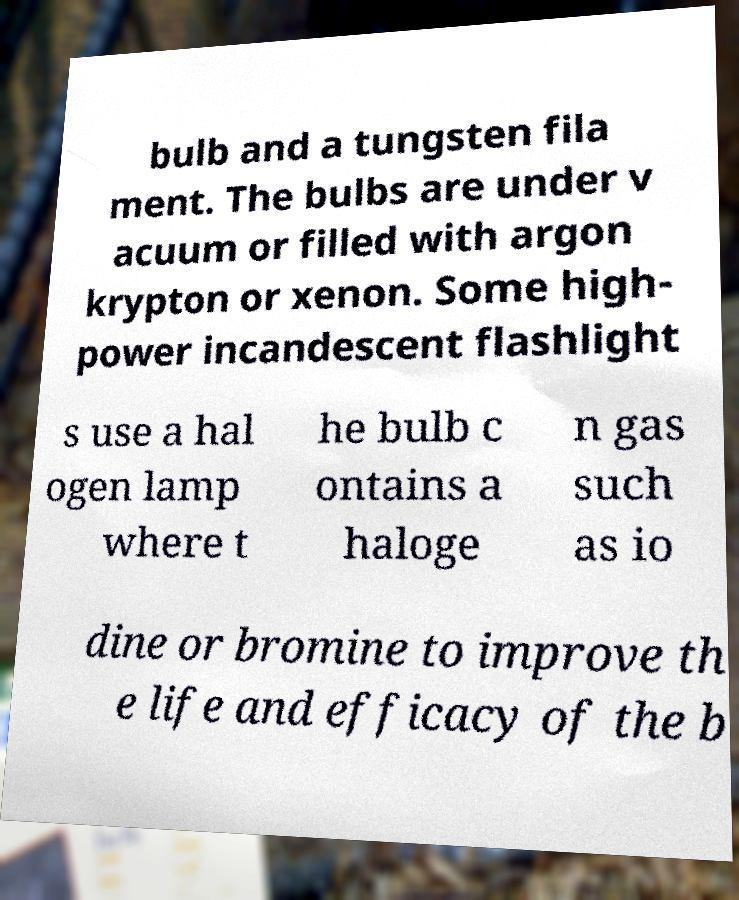Can you accurately transcribe the text from the provided image for me? bulb and a tungsten fila ment. The bulbs are under v acuum or filled with argon krypton or xenon. Some high- power incandescent flashlight s use a hal ogen lamp where t he bulb c ontains a haloge n gas such as io dine or bromine to improve th e life and efficacy of the b 